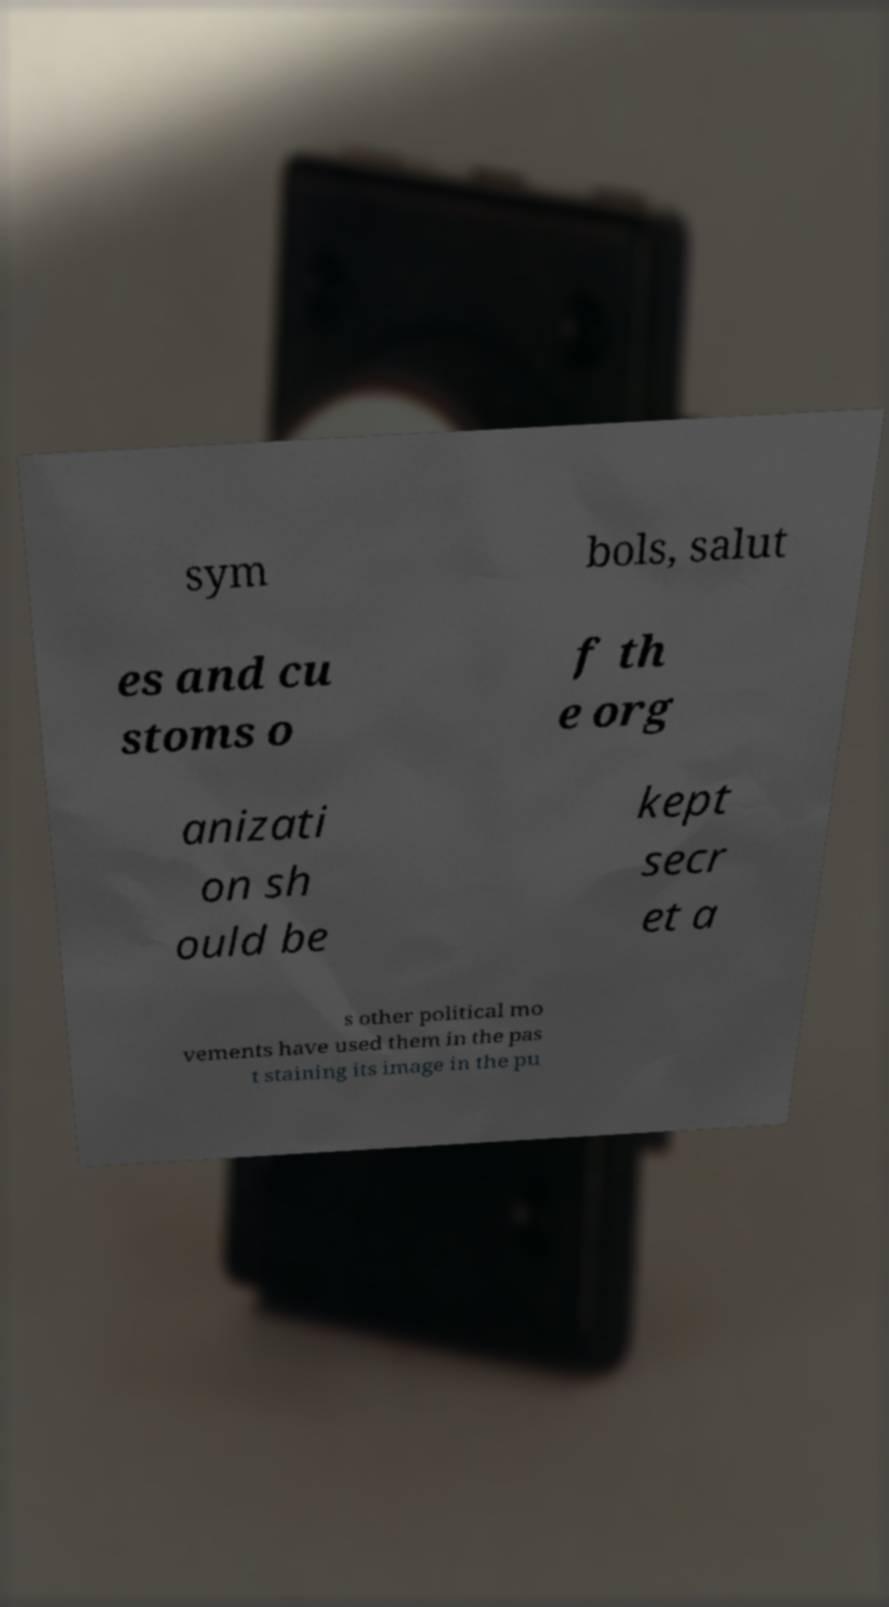Please identify and transcribe the text found in this image. sym bols, salut es and cu stoms o f th e org anizati on sh ould be kept secr et a s other political mo vements have used them in the pas t staining its image in the pu 